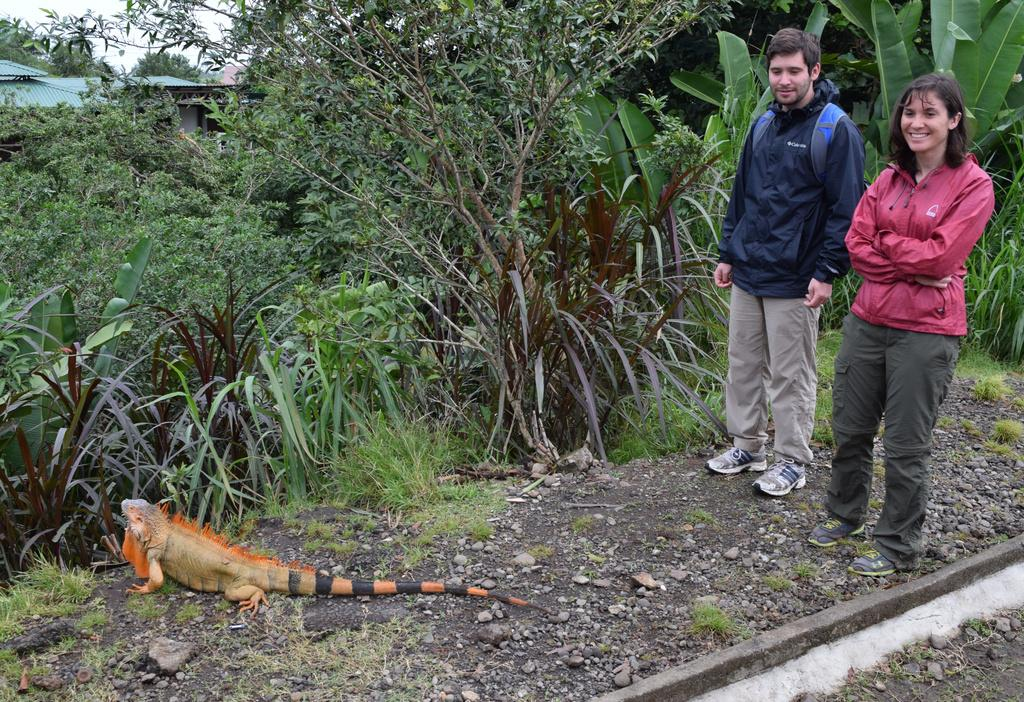How many people are present in the image? There are two people in the image. What is on the ground in the image? There is a reptile on the ground in the image. What can be seen in the background of the image? There are trees, shelters, and the sky visible in the background of the image. What type of powder is being used by the people in the image? There is no powder present in the image; it features two people and a reptile on the ground. What type of voyage are the people embarking on in the image? There is no indication of a voyage in the image; it simply shows two people and a reptile on the ground. 